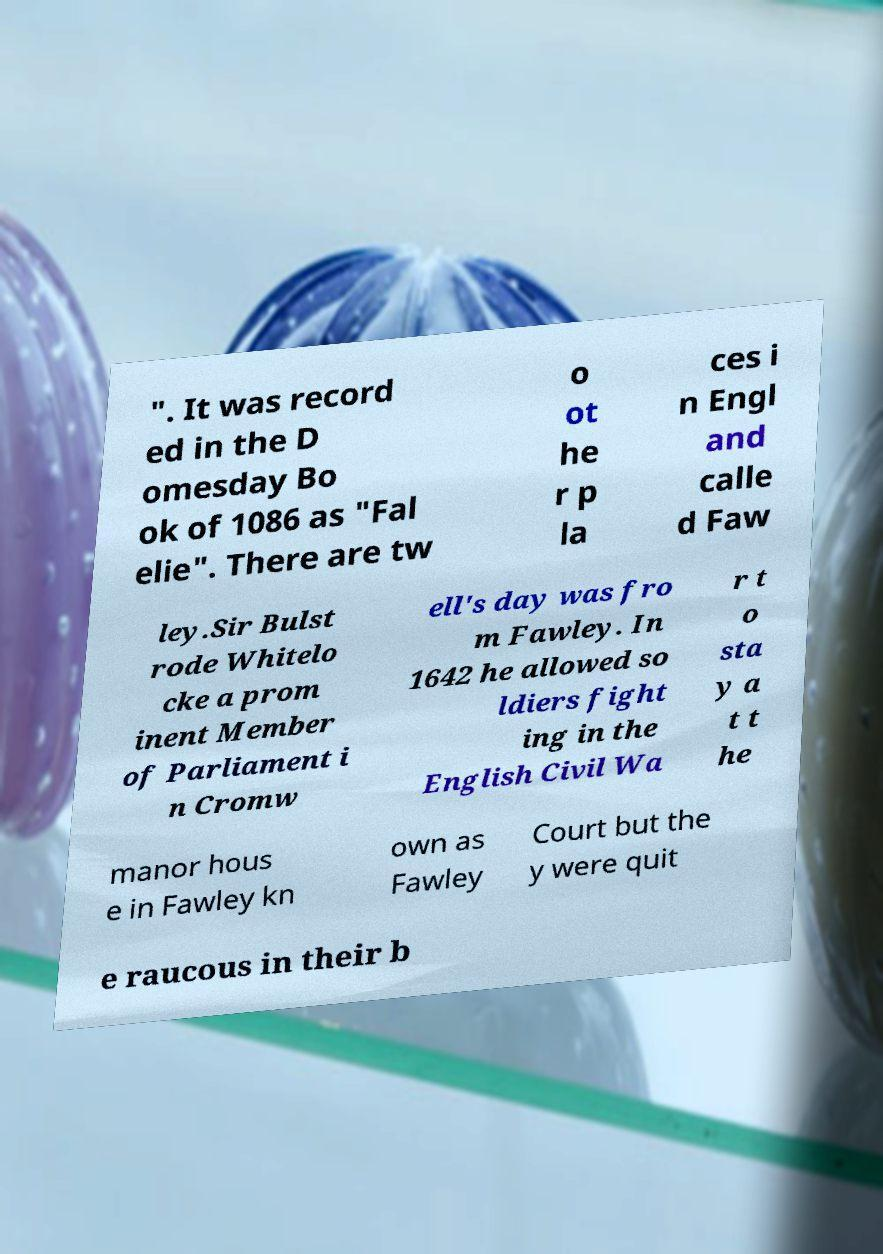There's text embedded in this image that I need extracted. Can you transcribe it verbatim? ". It was record ed in the D omesday Bo ok of 1086 as "Fal elie". There are tw o ot he r p la ces i n Engl and calle d Faw ley.Sir Bulst rode Whitelo cke a prom inent Member of Parliament i n Cromw ell's day was fro m Fawley. In 1642 he allowed so ldiers fight ing in the English Civil Wa r t o sta y a t t he manor hous e in Fawley kn own as Fawley Court but the y were quit e raucous in their b 